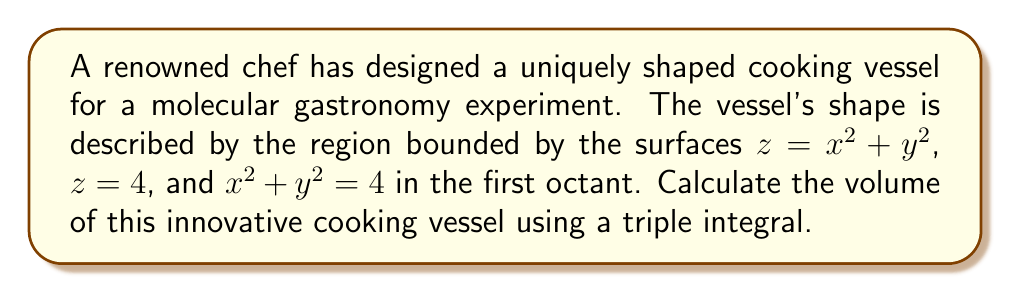What is the answer to this math problem? To calculate the volume of this uniquely shaped cooking vessel, we need to set up and evaluate a triple integral. Let's approach this step-by-step:

1) First, we need to determine the limits of integration:
   - The vessel is in the first octant, so $x, y, z \geq 0$
   - From $x^2 + y^2 = 4$, we get $0 \leq r \leq 2$ in polar coordinates
   - The height is bounded by $x^2 + y^2 \leq z \leq 4$

2) We'll use cylindrical coordinates for this integral:
   $x = r\cos\theta$, $y = r\sin\theta$, $z = z$

3) The volume integral in cylindrical coordinates is:
   $$V = \int_0^{2\pi} \int_0^2 \int_{r^2}^4 r \, dz \, dr \, d\theta$$

4) Let's evaluate the integral:
   $$V = \int_0^{2\pi} \int_0^2 r(4-r^2) \, dr \, d\theta$$

5) Integrate with respect to $r$:
   $$V = \int_0^{2\pi} \left[2r^2 - \frac{r^4}{4}\right]_0^2 \, d\theta$$
   $$= \int_0^{2\pi} \left(8 - 1\right) \, d\theta = 7\int_0^{2\pi} \, d\theta$$

6) Finally, integrate with respect to $\theta$:
   $$V = 7 \cdot 2\pi = 14\pi$$

Therefore, the volume of the cooking vessel is $14\pi$ cubic units.
Answer: $14\pi$ cubic units 